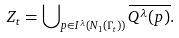<formula> <loc_0><loc_0><loc_500><loc_500>Z _ { t } = \bigcup \nolimits _ { p \in I ^ { \lambda } ( N _ { 1 } ( \Gamma _ { t } ) ) } \overline { Q ^ { \lambda } ( p ) } .</formula> 